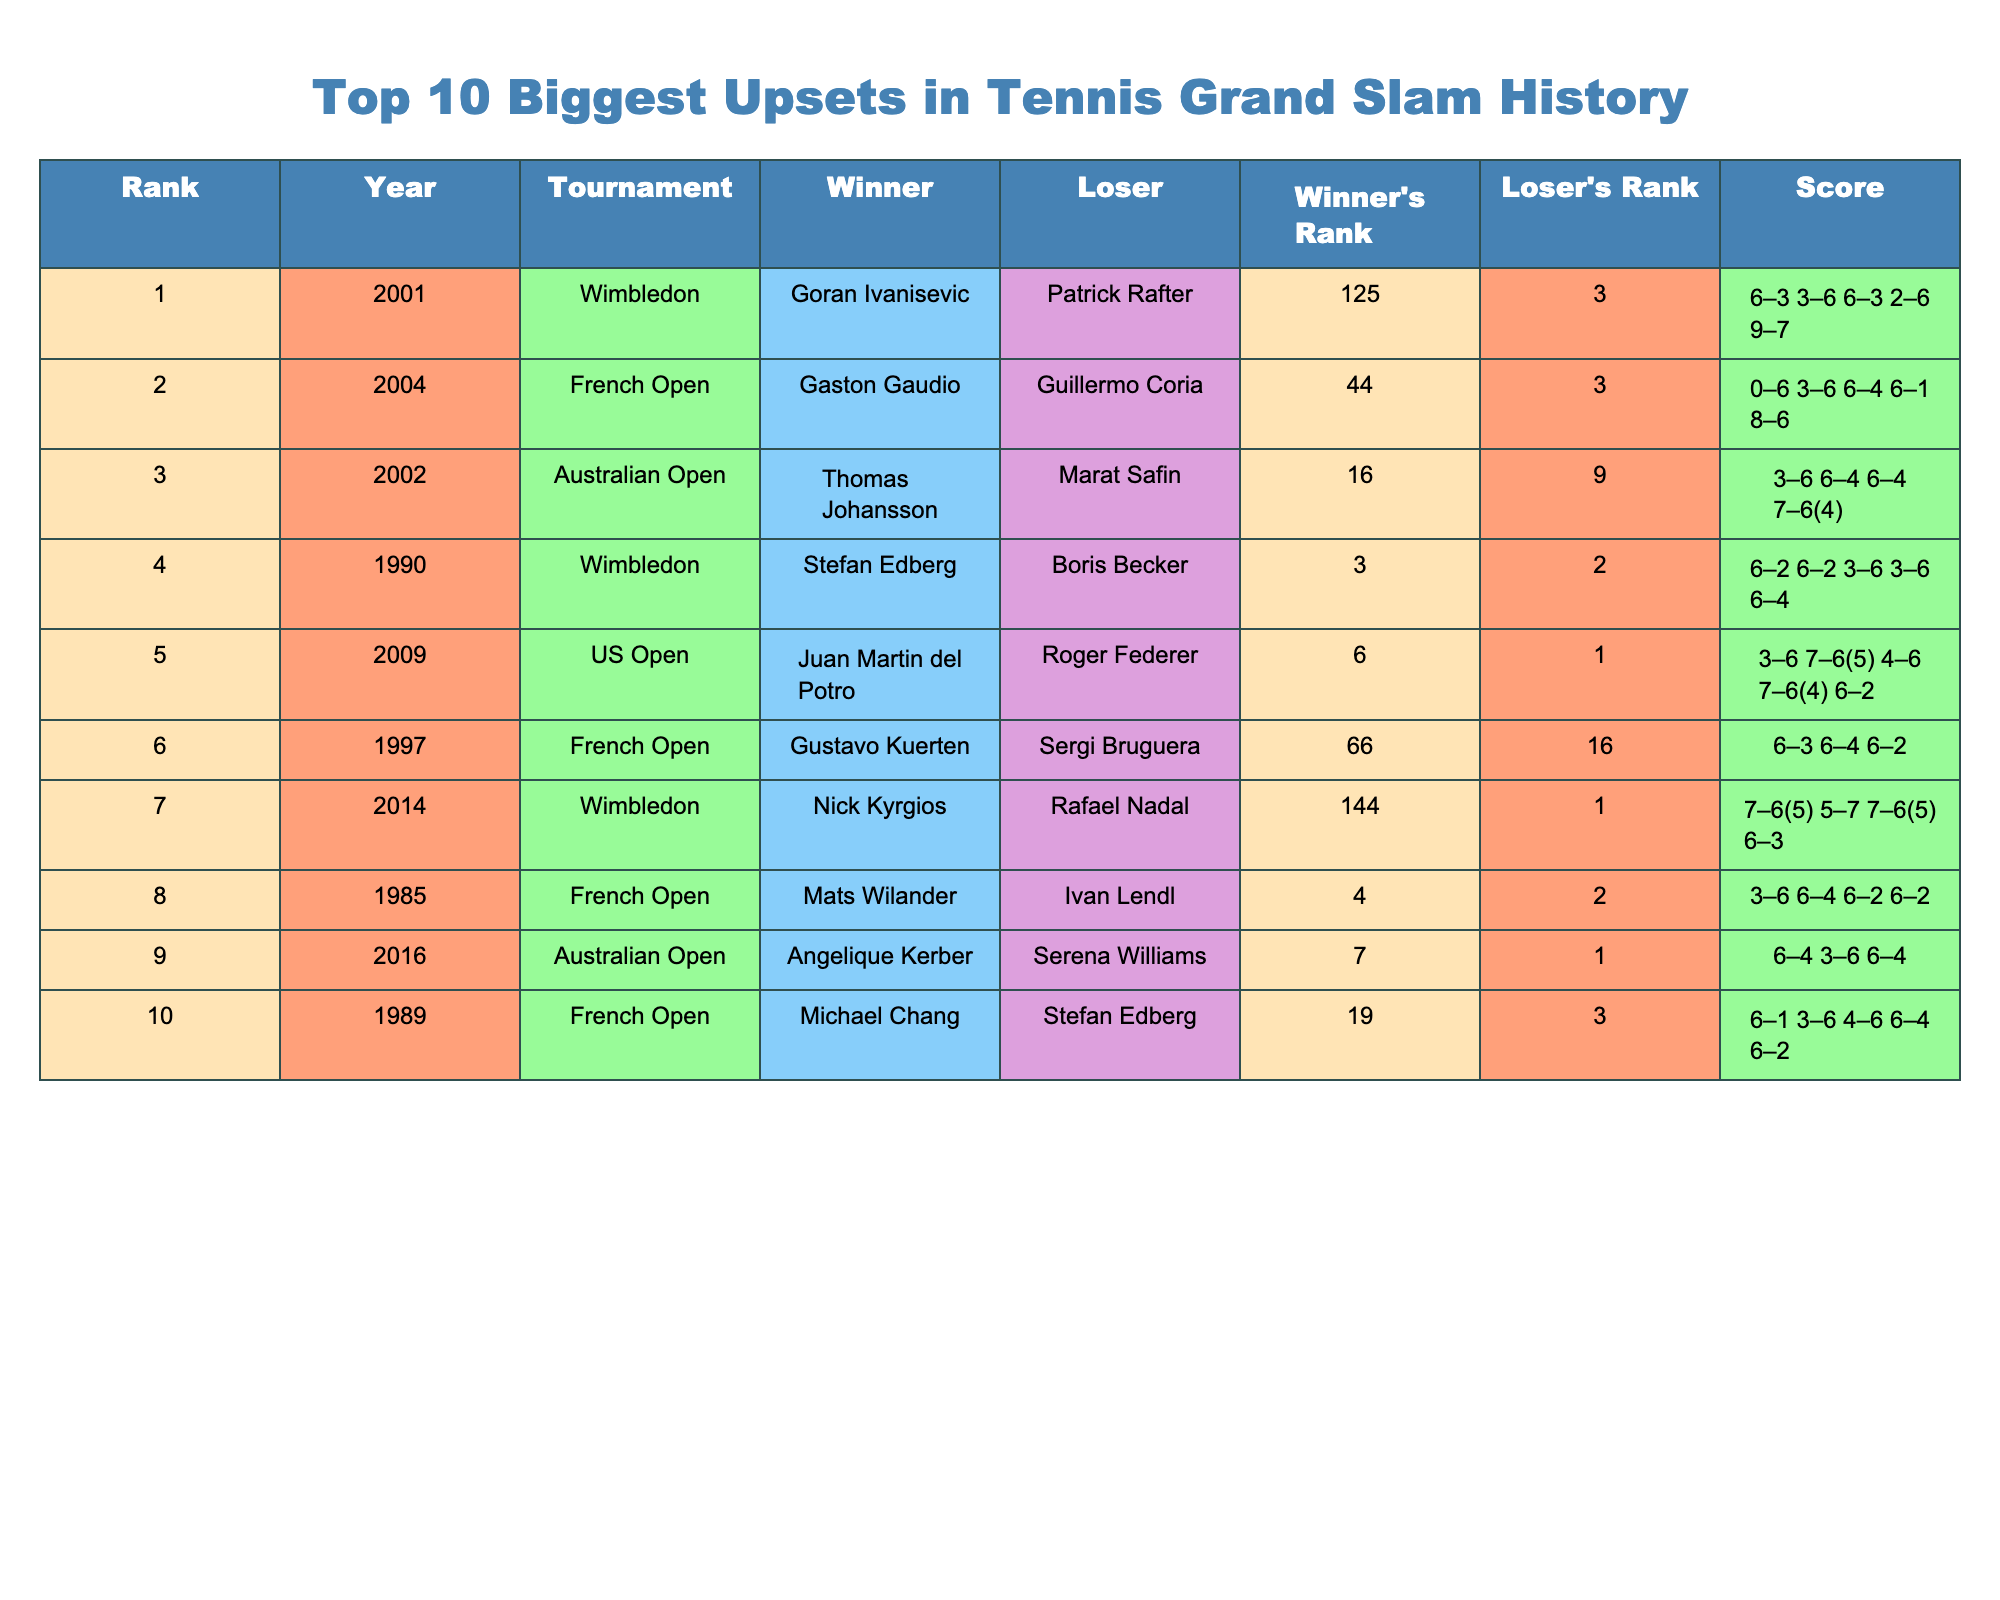What was the highest-ranked player to lose in a Grand Slam upset? The table shows that the highest-ranked player to lose was Rafael Nadal, who was ranked 1 when he lost to Nick Kyrgios in 2014.
Answer: Rafael Nadal Which year had the biggest upset according to the ranking? According to the ranking in the table, the biggest upset was in 2001 when Goran Ivanisevic, ranked 125, defeated Patrick Rafter, who was ranked 3.
Answer: 2001 How many upsets involved a player ranked outside the top 100? The table indicates that Goran Ivanisevic (ranked 125) and Nick Kyrgios (ranked 144) were both outside the top 100 when they won their respective matches, making a total of 2 upsets.
Answer: 2 What is the average rank of the winners? To find the average rank of the winners, we sum their ranks: 125 + 44 + 16 + 3 + 6 + 66 + 144 + 4 + 7 + 19 = 434. There are 10 winners, so the average rank is 434 / 10 = 43.4.
Answer: 43.4 Which match had the closest score in a Grand Slam upset? The closest score in the table is the match between Goran Ivanisevic and Patrick Rafter, which ended 9-7 in the fifth set. Therefore, this match had the closest score.
Answer: Goran Ivanisevic vs. Patrick Rafter Did any upset winner defeat a player ranked 2nd? Yes, Mats Wilander, who was ranked 4, defeated Ivan Lendl, who was ranked 2 during the 1985 French Open.
Answer: Yes What is the difference in rank between the lowest and highest-ranked winners? The lowest-ranked winner is Nick Kyrgios (ranked 144) and the highest is Gustavo Kuerten (ranked 66). The difference is 144 - 66 = 78.
Answer: 78 How many matches featured a final set tiebreak? There were two matches that featured a final set tiebreak: Thomas Johansson vs. Marat Safin and Juan Martin del Potro vs. Roger Federer.
Answer: 2 Which tournament had the most representatives in the table? By reviewing the tournament column, it can be observed that the French Open had 4 representatives, which is more than any other tournament.
Answer: French Open What was the significance of Angelique Kerber's win in 2016? Angelique Kerber, ranked 7, defeated the world number 1, Serena Williams, showing a significant upset in women's tennis at the time.
Answer: Significant upset Which two matches had the highest score in sets overall? The matches between Goran Ivanisevic vs. Patrick Rafter and Michael Chang vs. Stefan Edberg had the highest score in sets overall with scores respectively of 6-3, 3-6, 6-3, 2-6, 9-7 and 6-1, 3-6, 4-6, 6-4, 6-2. This gives 5 sets in both instances.
Answer: Goran Ivanisevic vs. Patrick Rafter and Michael Chang vs. Stefan Edberg 